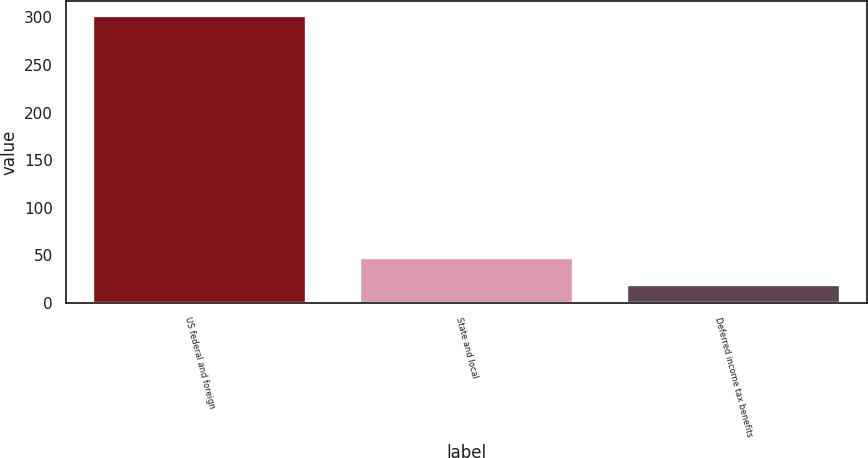<chart> <loc_0><loc_0><loc_500><loc_500><bar_chart><fcel>US federal and foreign<fcel>State and local<fcel>Deferred income tax benefits<nl><fcel>301.9<fcel>47.29<fcel>19<nl></chart> 